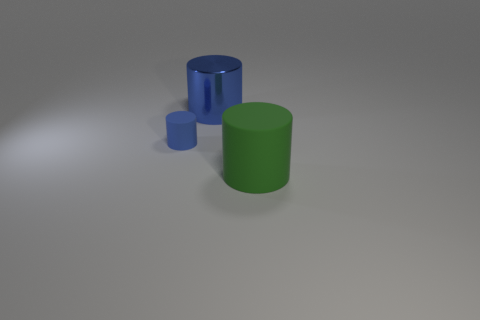Add 2 purple rubber blocks. How many objects exist? 5 Add 3 large cyan things. How many large cyan things exist? 3 Subtract 0 blue cubes. How many objects are left? 3 Subtract all small blue rubber cylinders. Subtract all green rubber objects. How many objects are left? 1 Add 3 green rubber cylinders. How many green rubber cylinders are left? 4 